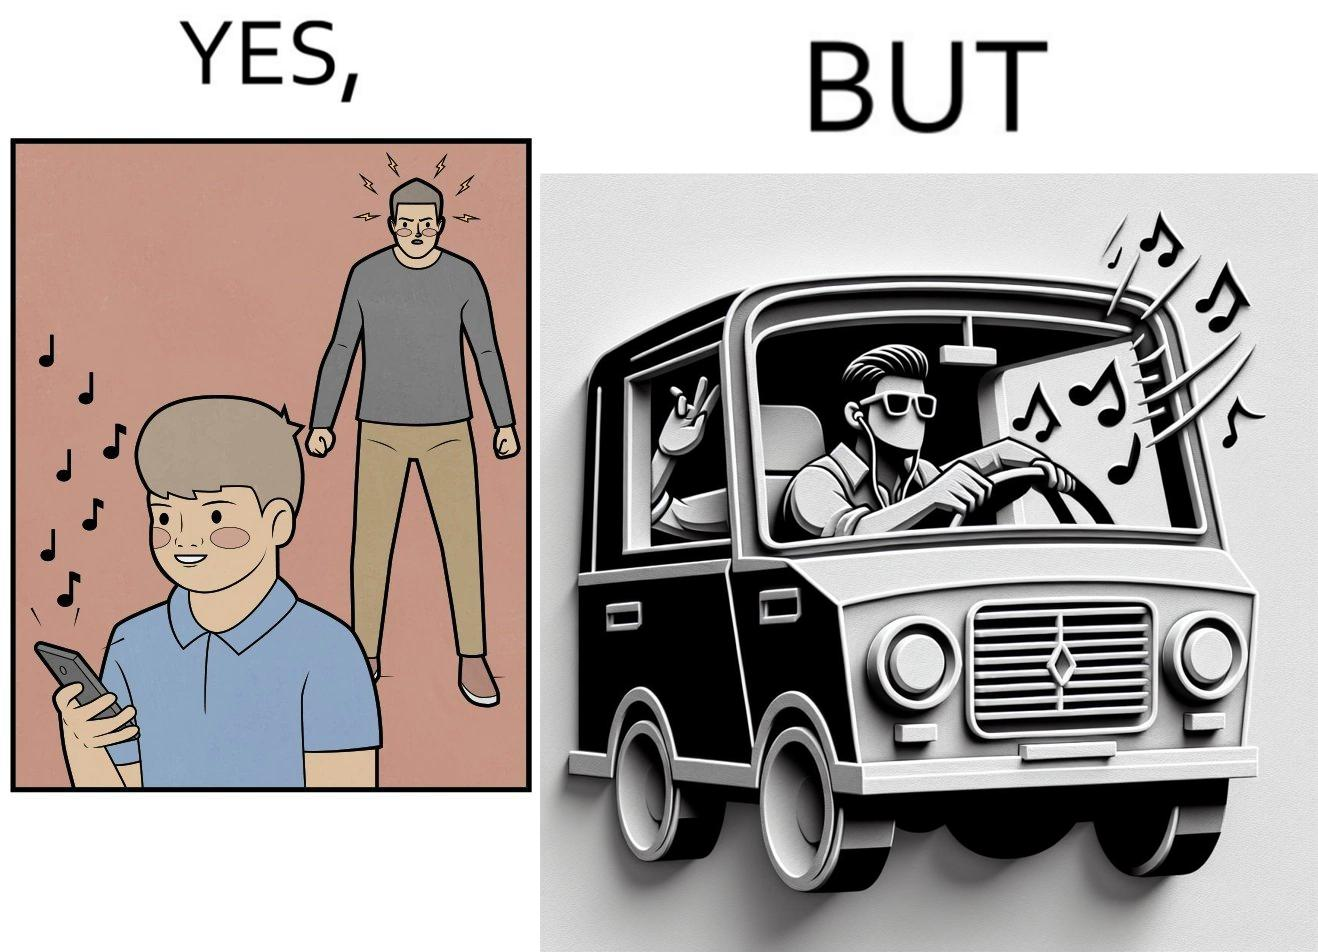Describe the content of this image. The image is funny because while the man does not like the boy playing music loudly on his phone, the man himself is okay with doing the same thing with his car and playing loud music in the car with the sound coming out of the car. 